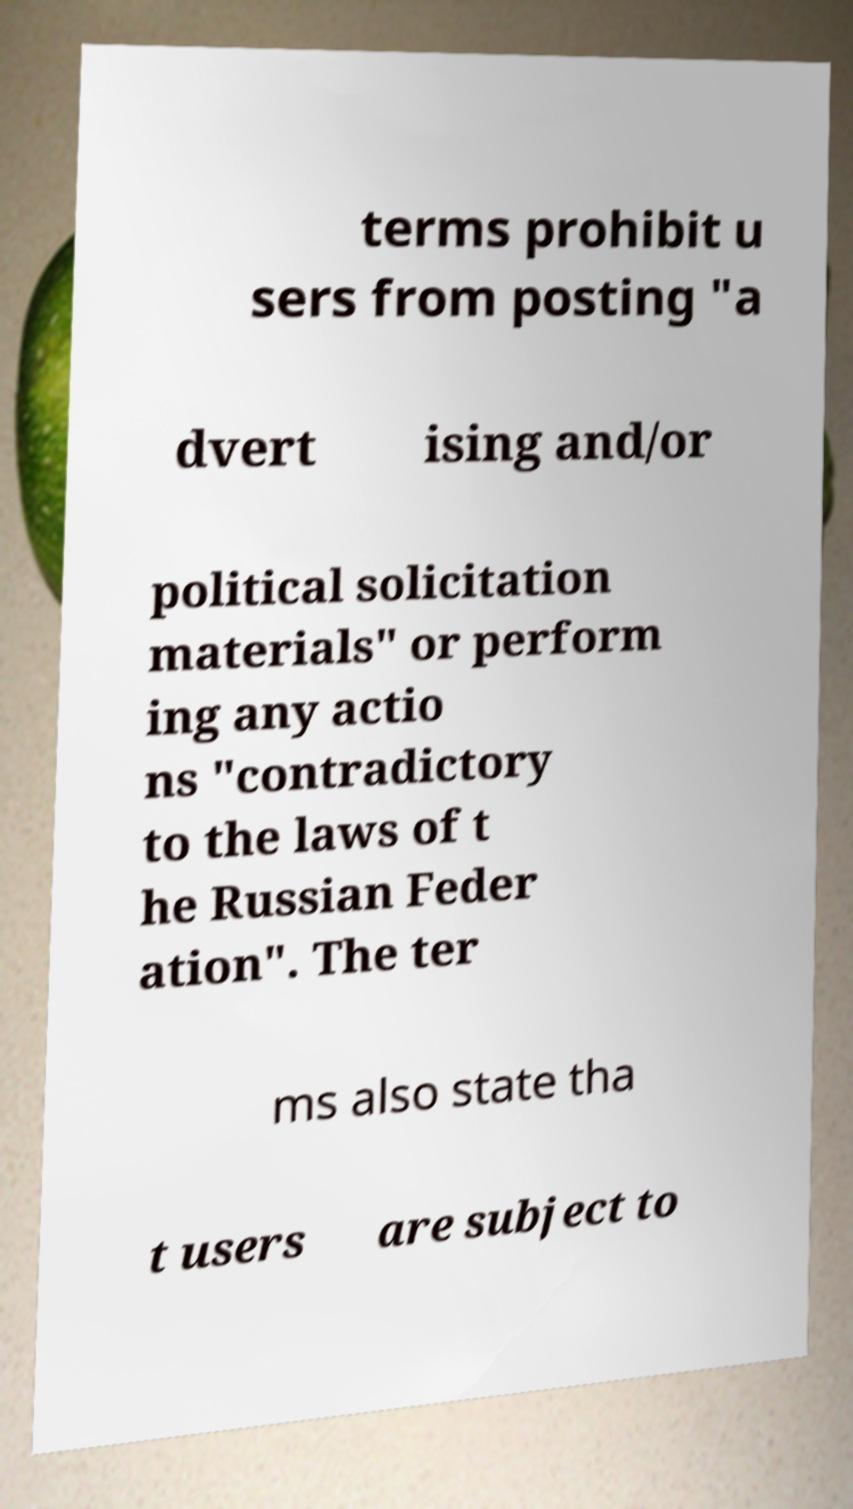What messages or text are displayed in this image? I need them in a readable, typed format. terms prohibit u sers from posting "a dvert ising and/or political solicitation materials" or perform ing any actio ns "contradictory to the laws of t he Russian Feder ation". The ter ms also state tha t users are subject to 